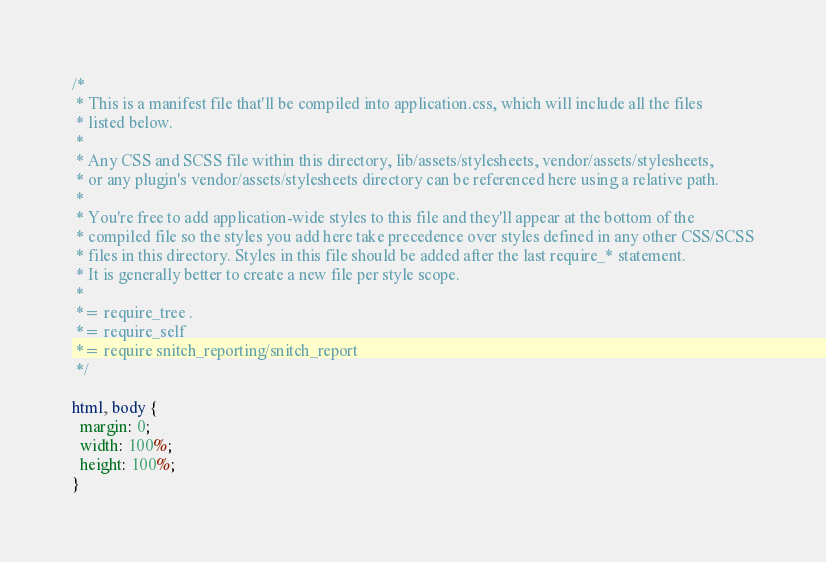<code> <loc_0><loc_0><loc_500><loc_500><_CSS_>/*
 * This is a manifest file that'll be compiled into application.css, which will include all the files
 * listed below.
 *
 * Any CSS and SCSS file within this directory, lib/assets/stylesheets, vendor/assets/stylesheets,
 * or any plugin's vendor/assets/stylesheets directory can be referenced here using a relative path.
 *
 * You're free to add application-wide styles to this file and they'll appear at the bottom of the
 * compiled file so the styles you add here take precedence over styles defined in any other CSS/SCSS
 * files in this directory. Styles in this file should be added after the last require_* statement.
 * It is generally better to create a new file per style scope.
 *
 *= require_tree .
 *= require_self
 *= require snitch_reporting/snitch_report
 */

html, body {
  margin: 0;
  width: 100%;
  height: 100%;
}
</code> 